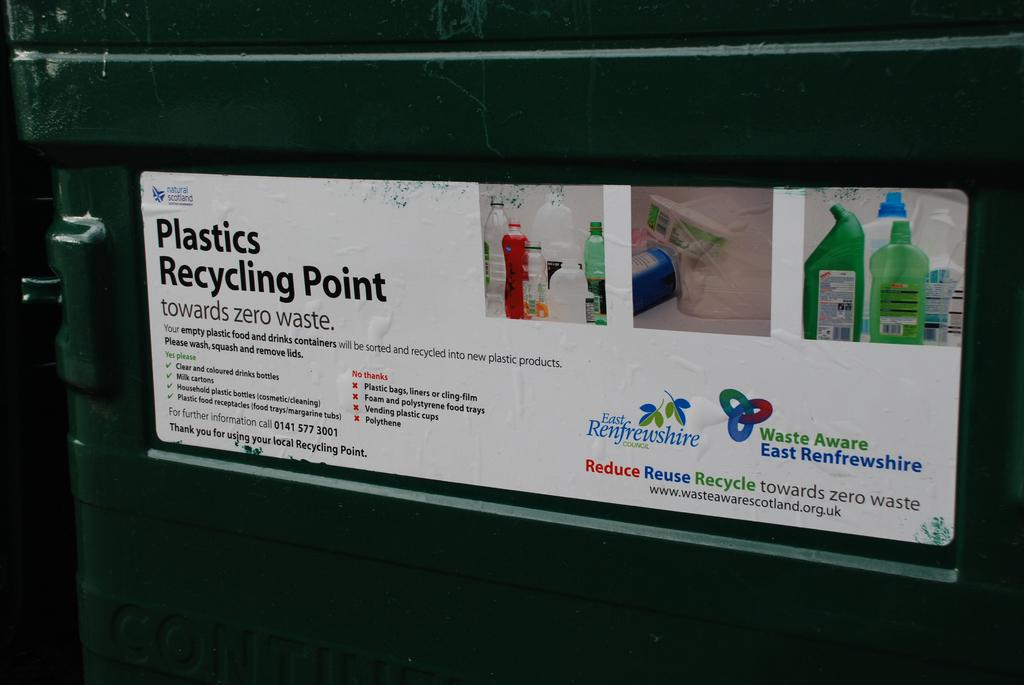<image>
Relay a brief, clear account of the picture shown. A recycling bin has a sticker than says Plastics Recycling Point. 